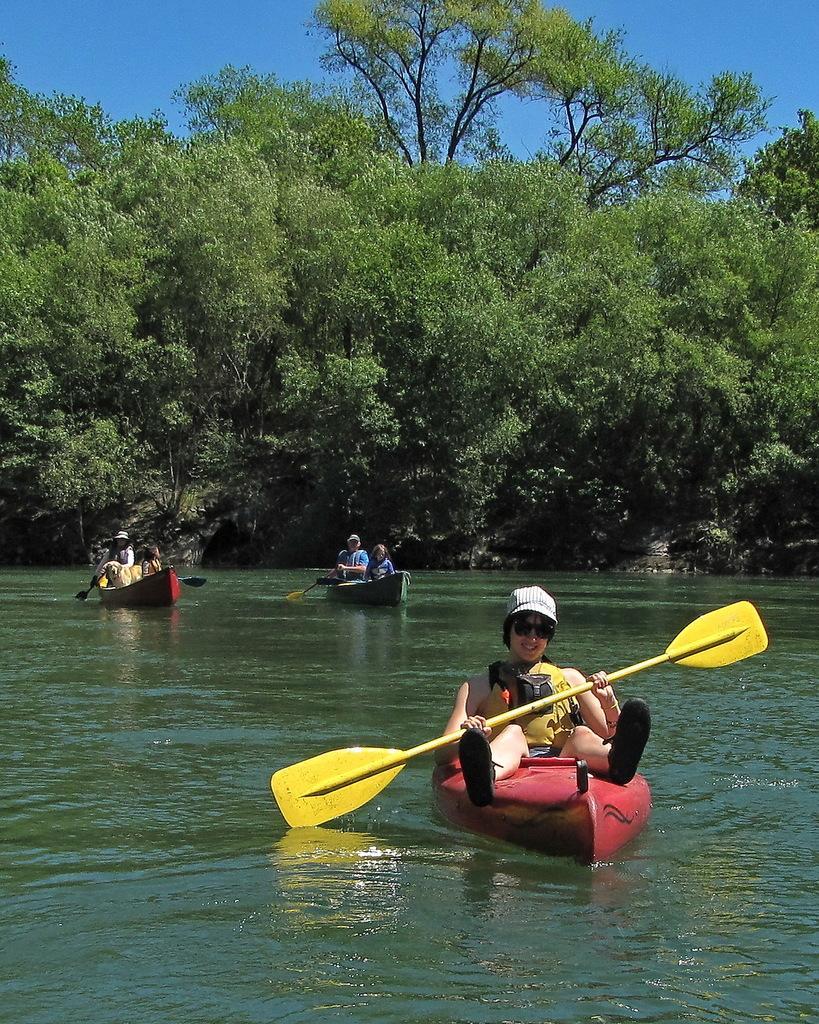Please provide a concise description of this image. In this image we can boats on the surface of water. We can see people on the boats. In the middle of the image, we can see the trees. At the top of the image, we can see the sky. 